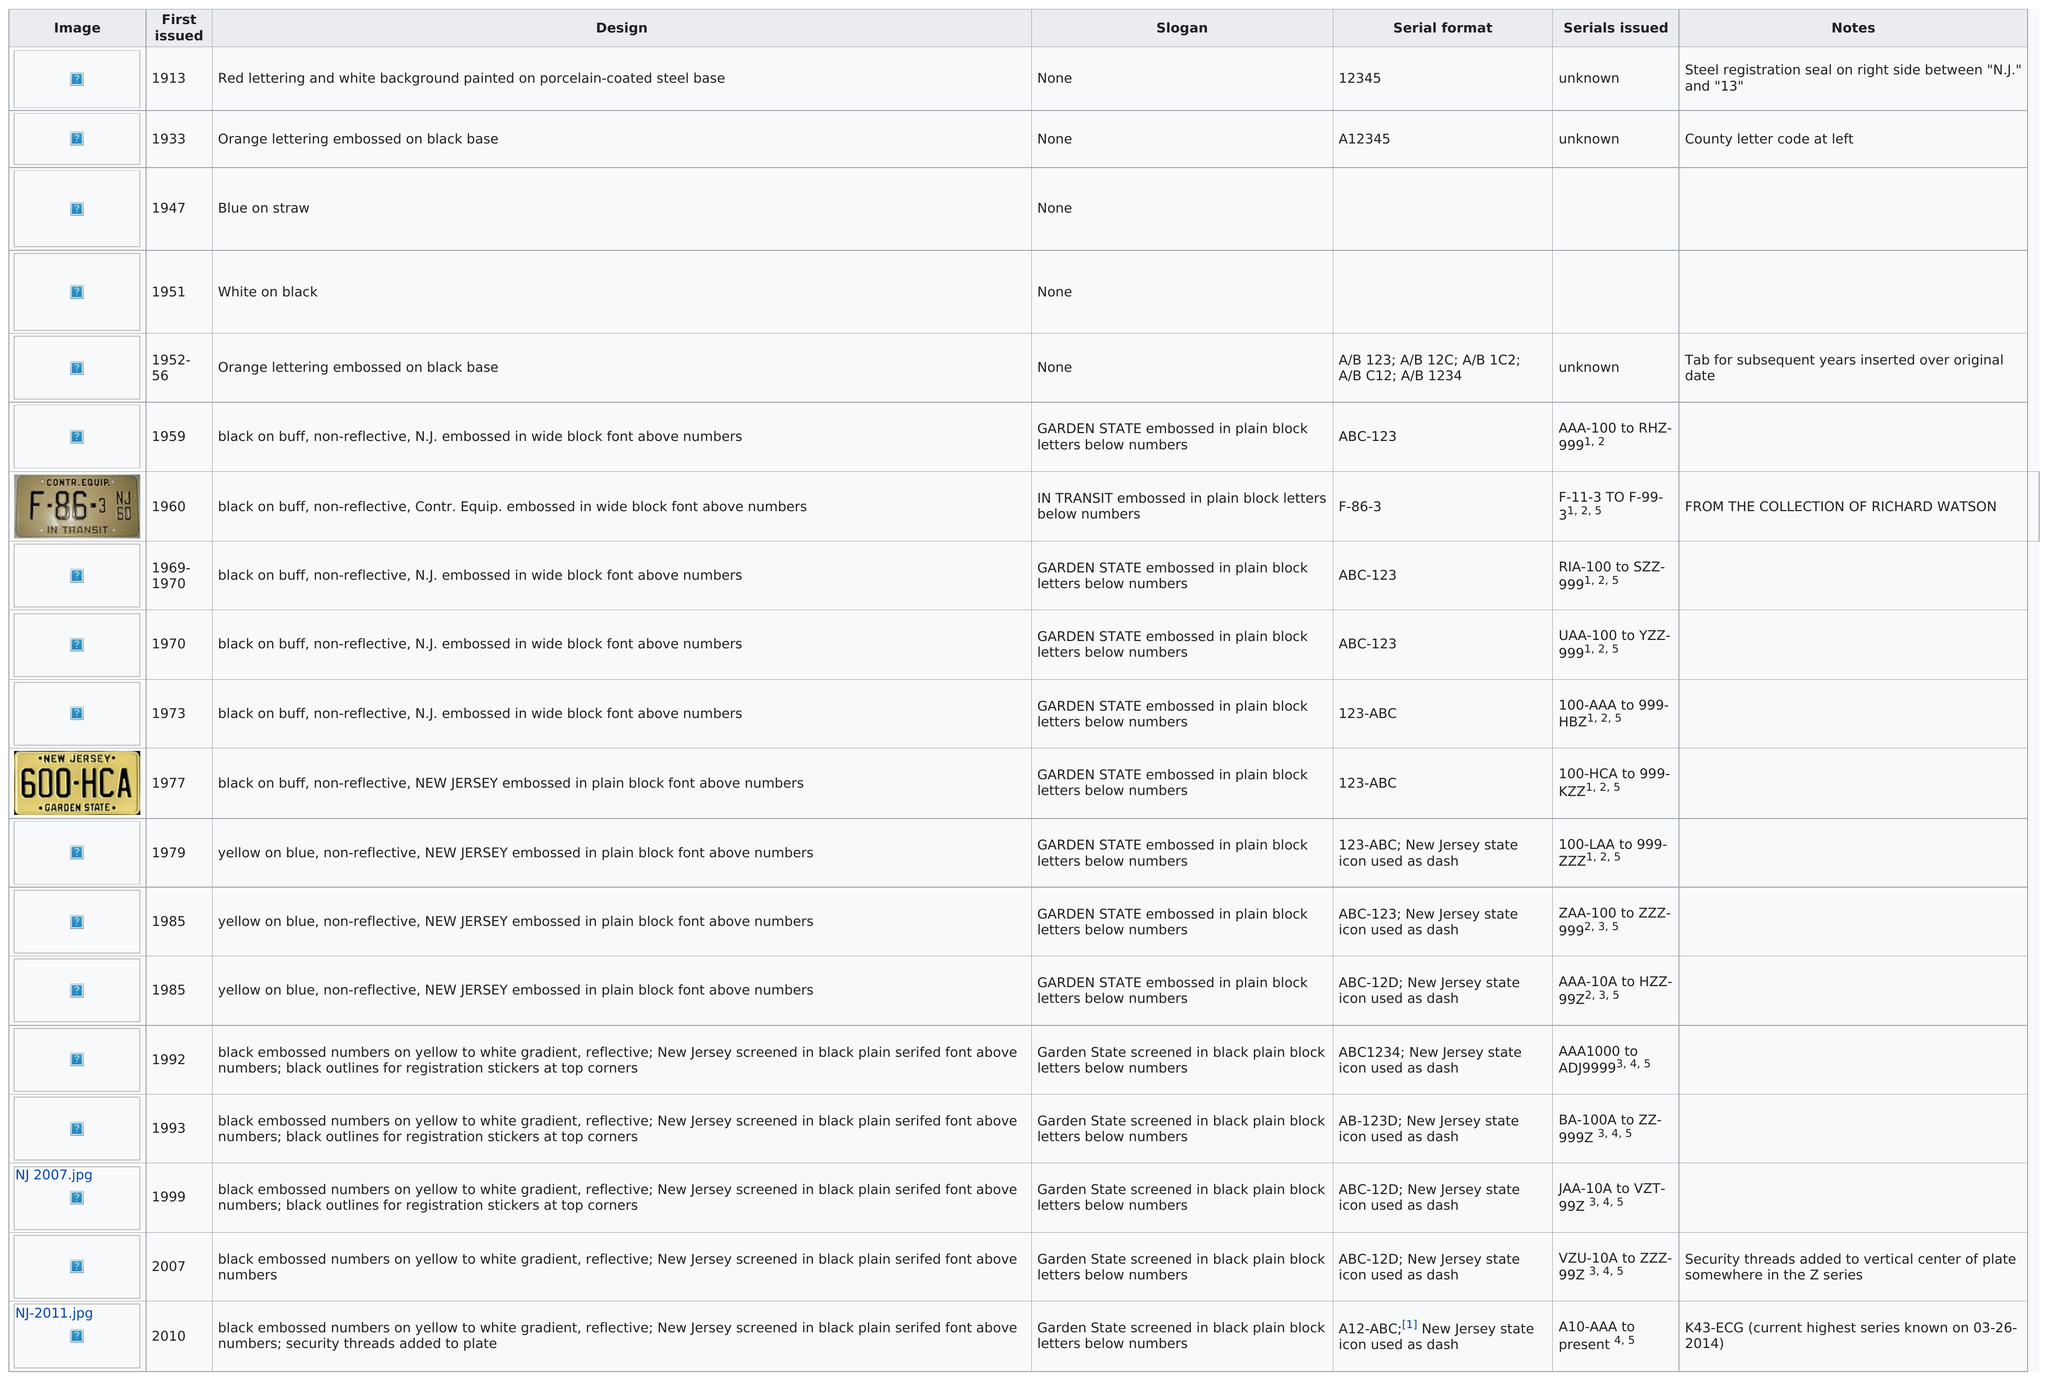Highlight a few significant elements in this photo. In total, 11 license plates featured black embossed numbers. Out of the 14 baseplates examined, 14 baseplates have slogans. Before 1960, a total of 6 license plates were issued. The passenger baseplate with red lettering and white background painted on a porcelain-coated steel base was issued for the longest amount of time before another was introduced. After 1970, four different colors of plates were issued. 